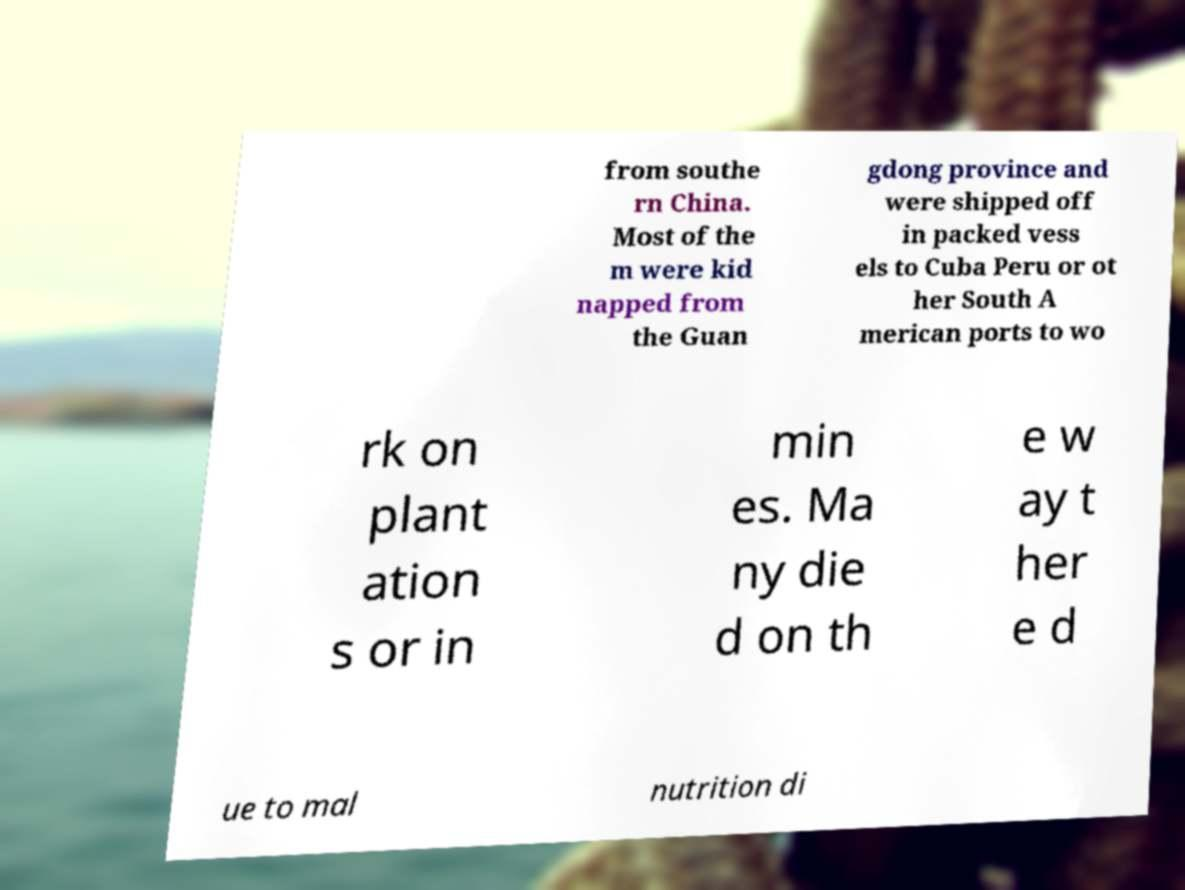What messages or text are displayed in this image? I need them in a readable, typed format. from southe rn China. Most of the m were kid napped from the Guan gdong province and were shipped off in packed vess els to Cuba Peru or ot her South A merican ports to wo rk on plant ation s or in min es. Ma ny die d on th e w ay t her e d ue to mal nutrition di 